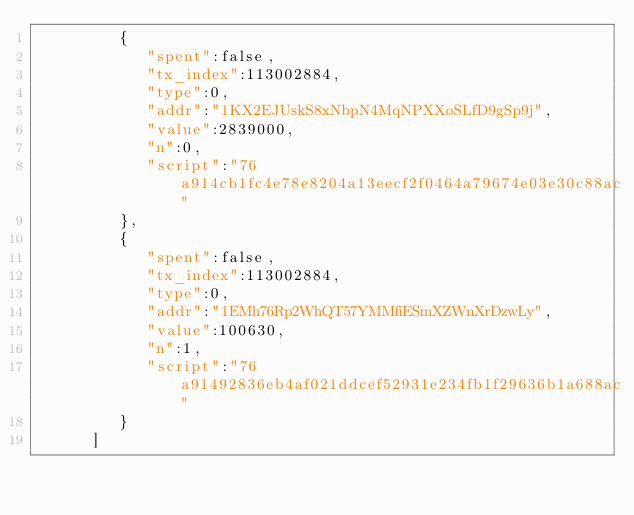<code> <loc_0><loc_0><loc_500><loc_500><_XML_>         {
            "spent":false,
            "tx_index":113002884,
            "type":0,
            "addr":"1KX2EJUskS8xNbpN4MqNPXXoSLfD9gSp9j",
            "value":2839000,
            "n":0,
            "script":"76a914cb1fc4e78e8204a13eecf2f0464a79674e03e30c88ac"
         },
         {
            "spent":false,
            "tx_index":113002884,
            "type":0,
            "addr":"1EMh76Rp2WhQT57YMMfiESmXZWnXrDzwLy",
            "value":100630,
            "n":1,
            "script":"76a91492836eb4af021ddcef52931e234fb1f29636b1a688ac"
         }
      ]</code> 